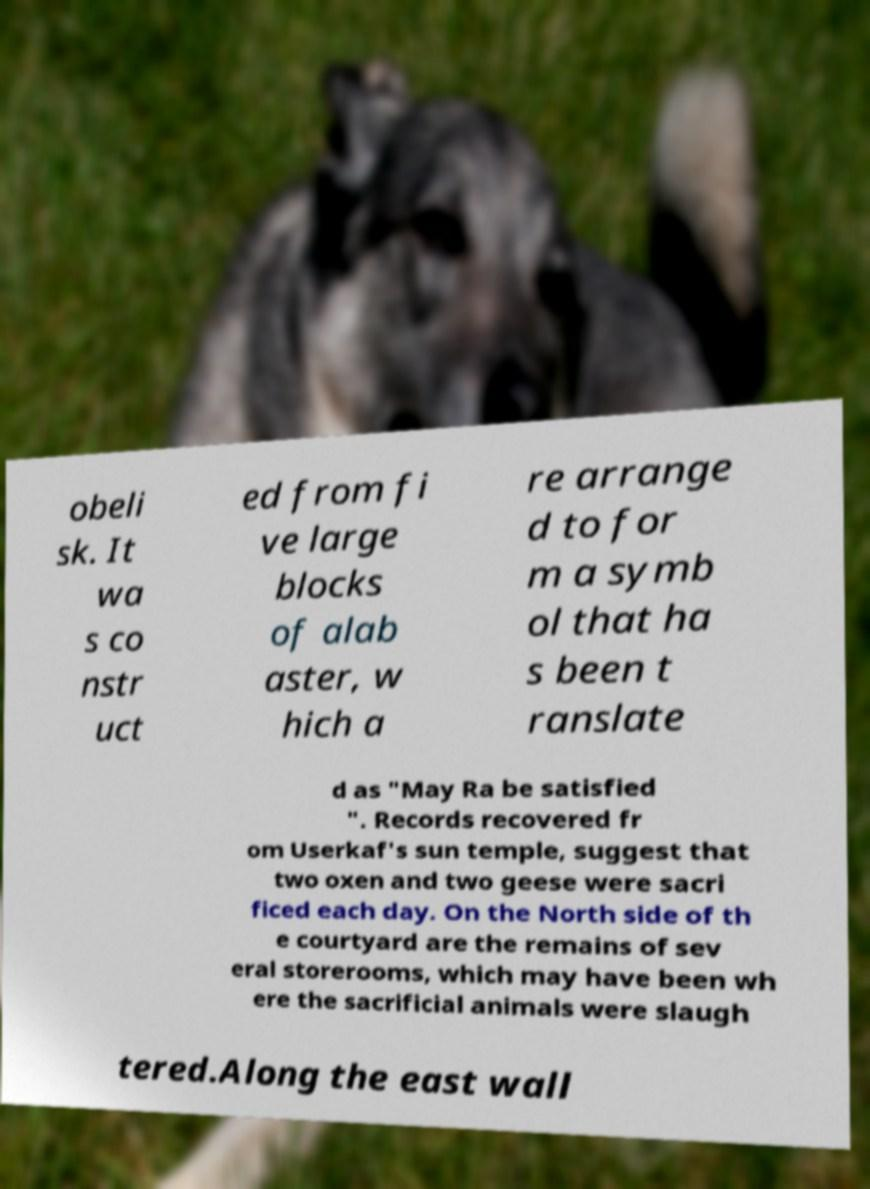Could you extract and type out the text from this image? obeli sk. It wa s co nstr uct ed from fi ve large blocks of alab aster, w hich a re arrange d to for m a symb ol that ha s been t ranslate d as "May Ra be satisfied ". Records recovered fr om Userkaf's sun temple, suggest that two oxen and two geese were sacri ficed each day. On the North side of th e courtyard are the remains of sev eral storerooms, which may have been wh ere the sacrificial animals were slaugh tered.Along the east wall 